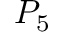<formula> <loc_0><loc_0><loc_500><loc_500>P _ { 5 }</formula> 